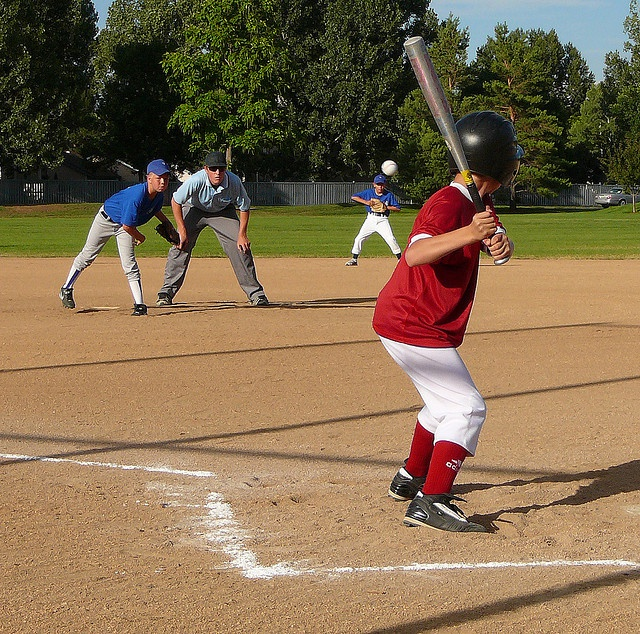Describe the objects in this image and their specific colors. I can see people in darkgreen, black, brown, lightgray, and maroon tones, people in darkgreen, black, gray, and tan tones, people in darkgreen, black, lightgray, blue, and darkgray tones, baseball bat in darkgreen, gray, black, and darkgray tones, and people in darkgreen, white, black, blue, and gray tones in this image. 